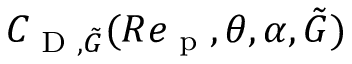Convert formula to latex. <formula><loc_0><loc_0><loc_500><loc_500>C _ { D , \tilde { G } } ( R e _ { p } , \theta , \alpha , \tilde { G } )</formula> 